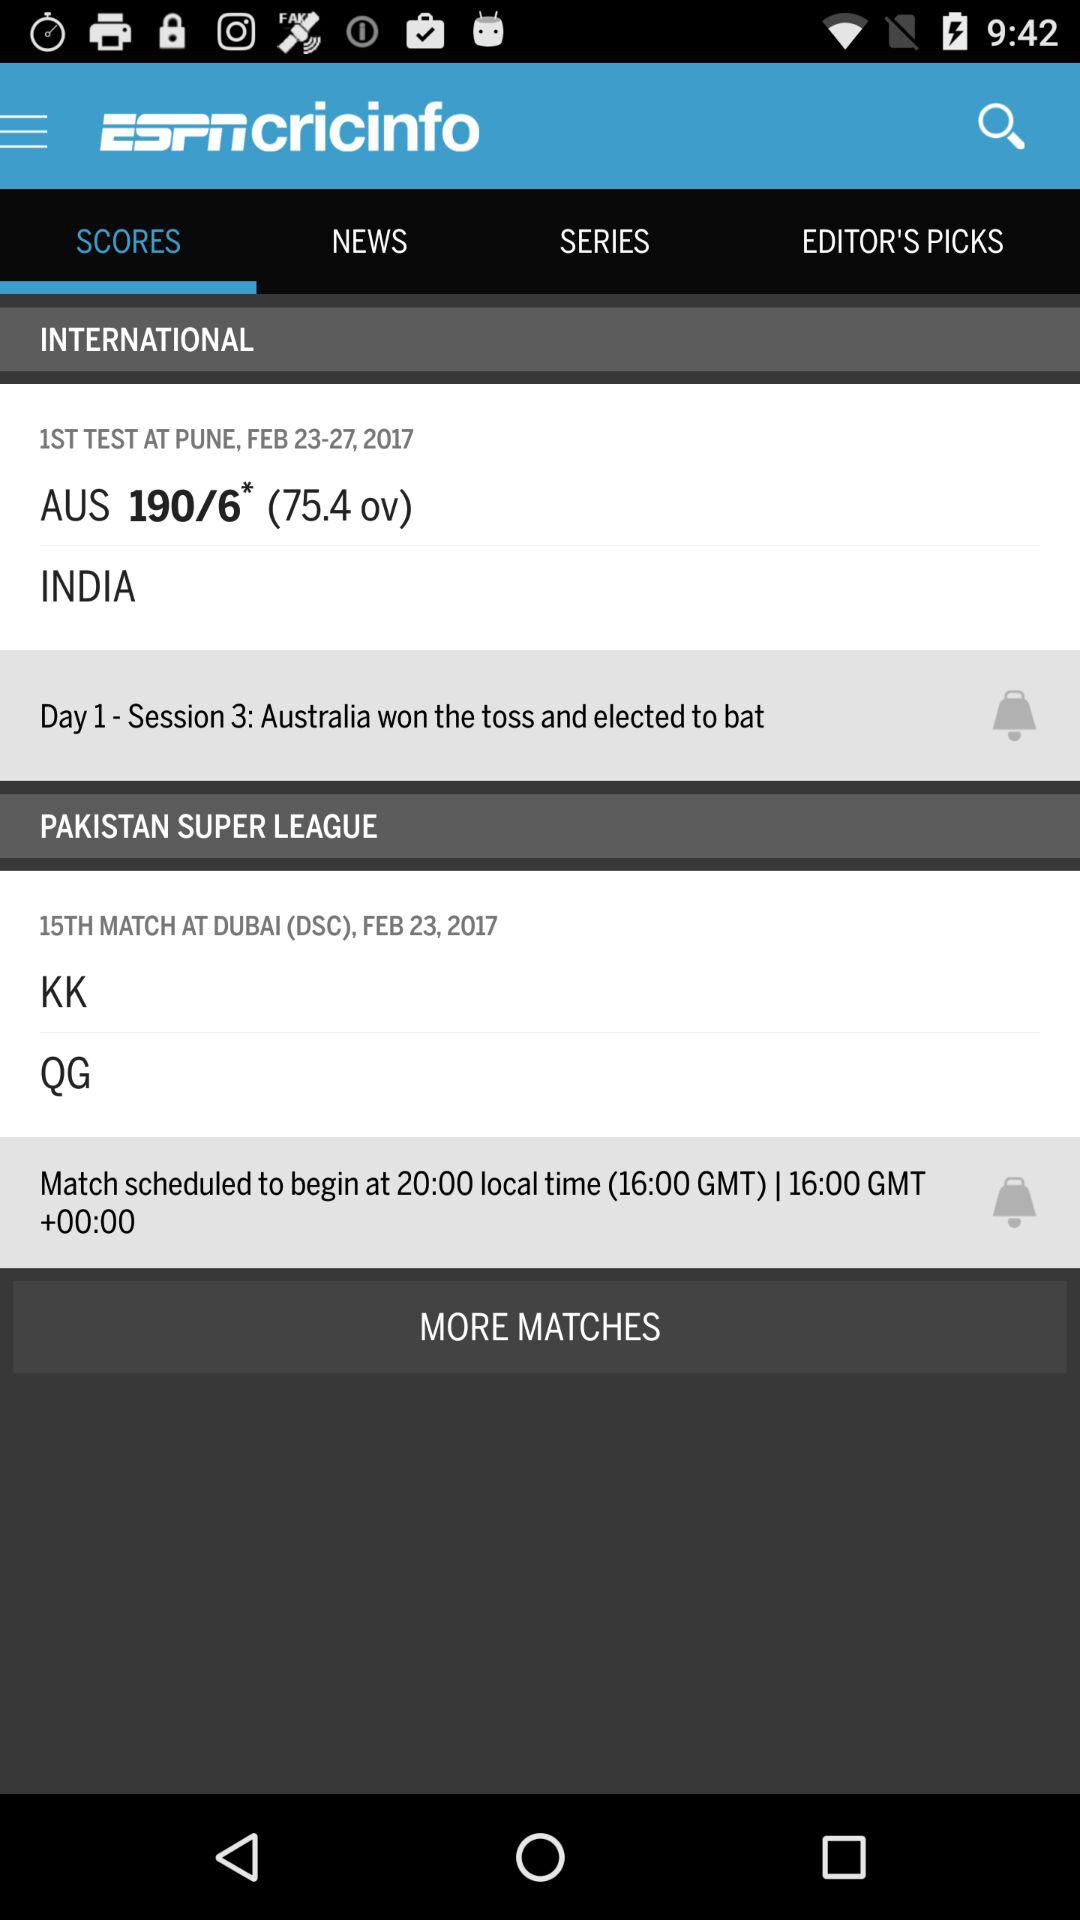Where is the first test being played? The first test is being played in Pune. 